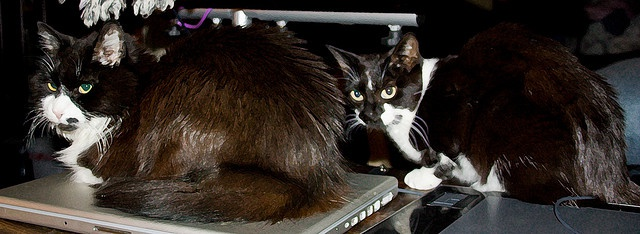Describe the objects in this image and their specific colors. I can see cat in black, maroon, and gray tones, cat in black, gray, and lightgray tones, and laptop in black, gray, and darkgray tones in this image. 